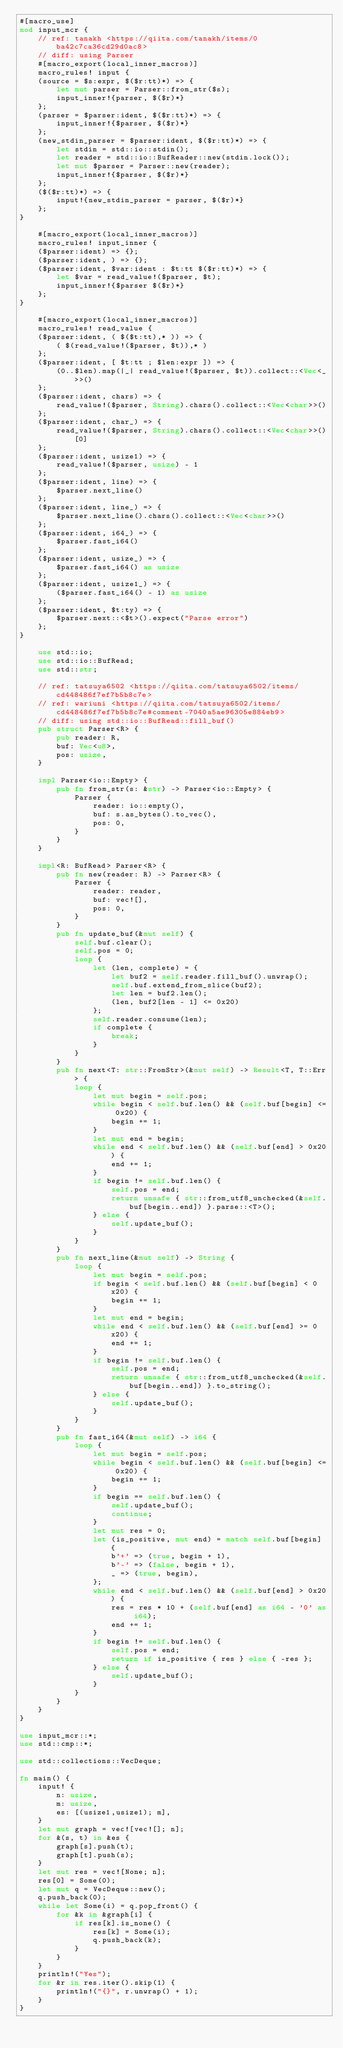Convert code to text. <code><loc_0><loc_0><loc_500><loc_500><_Rust_>#[macro_use]
mod input_mcr {
    // ref: tanakh <https://qiita.com/tanakh/items/0ba42c7ca36cd29d0ac8>
    // diff: using Parser
    #[macro_export(local_inner_macros)]
    macro_rules! input {
    (source = $s:expr, $($r:tt)*) => {
        let mut parser = Parser::from_str($s);
        input_inner!{parser, $($r)*}
    };
    (parser = $parser:ident, $($r:tt)*) => {
        input_inner!{$parser, $($r)*}
    };
    (new_stdin_parser = $parser:ident, $($r:tt)*) => {
        let stdin = std::io::stdin();
        let reader = std::io::BufReader::new(stdin.lock());
        let mut $parser = Parser::new(reader);
        input_inner!{$parser, $($r)*}
    };
    ($($r:tt)*) => {
        input!{new_stdin_parser = parser, $($r)*}
    };
}

    #[macro_export(local_inner_macros)]
    macro_rules! input_inner {
    ($parser:ident) => {};
    ($parser:ident, ) => {};
    ($parser:ident, $var:ident : $t:tt $($r:tt)*) => {
        let $var = read_value!($parser, $t);
        input_inner!{$parser $($r)*}
    };
}

    #[macro_export(local_inner_macros)]
    macro_rules! read_value {
    ($parser:ident, ( $($t:tt),* )) => {
        ( $(read_value!($parser, $t)),* )
    };
    ($parser:ident, [ $t:tt ; $len:expr ]) => {
        (0..$len).map(|_| read_value!($parser, $t)).collect::<Vec<_>>()
    };
    ($parser:ident, chars) => {
        read_value!($parser, String).chars().collect::<Vec<char>>()
    };
    ($parser:ident, char_) => {
        read_value!($parser, String).chars().collect::<Vec<char>>()[0]
    };
    ($parser:ident, usize1) => {
        read_value!($parser, usize) - 1
    };
    ($parser:ident, line) => {
        $parser.next_line()
    };
    ($parser:ident, line_) => {
        $parser.next_line().chars().collect::<Vec<char>>()
    };
    ($parser:ident, i64_) => {
        $parser.fast_i64()
    };
    ($parser:ident, usize_) => {
        $parser.fast_i64() as usize
    };
    ($parser:ident, usize1_) => {
        ($parser.fast_i64() - 1) as usize
    };
    ($parser:ident, $t:ty) => {
        $parser.next::<$t>().expect("Parse error")
    };
}

    use std::io;
    use std::io::BufRead;
    use std::str;

    // ref: tatsuya6502 <https://qiita.com/tatsuya6502/items/cd448486f7ef7b5b8c7e>
    // ref: wariuni <https://qiita.com/tatsuya6502/items/cd448486f7ef7b5b8c7e#comment-7040a5ae96305e884eb9>
    // diff: using std::io::BufRead::fill_buf()
    pub struct Parser<R> {
        pub reader: R,
        buf: Vec<u8>,
        pos: usize,
    }

    impl Parser<io::Empty> {
        pub fn from_str(s: &str) -> Parser<io::Empty> {
            Parser {
                reader: io::empty(),
                buf: s.as_bytes().to_vec(),
                pos: 0,
            }
        }
    }

    impl<R: BufRead> Parser<R> {
        pub fn new(reader: R) -> Parser<R> {
            Parser {
                reader: reader,
                buf: vec![],
                pos: 0,
            }
        }
        pub fn update_buf(&mut self) {
            self.buf.clear();
            self.pos = 0;
            loop {
                let (len, complete) = {
                    let buf2 = self.reader.fill_buf().unwrap();
                    self.buf.extend_from_slice(buf2);
                    let len = buf2.len();
                    (len, buf2[len - 1] <= 0x20)
                };
                self.reader.consume(len);
                if complete {
                    break;
                }
            }
        }
        pub fn next<T: str::FromStr>(&mut self) -> Result<T, T::Err> {
            loop {
                let mut begin = self.pos;
                while begin < self.buf.len() && (self.buf[begin] <= 0x20) {
                    begin += 1;
                }
                let mut end = begin;
                while end < self.buf.len() && (self.buf[end] > 0x20) {
                    end += 1;
                }
                if begin != self.buf.len() {
                    self.pos = end;
                    return unsafe { str::from_utf8_unchecked(&self.buf[begin..end]) }.parse::<T>();
                } else {
                    self.update_buf();
                }
            }
        }
        pub fn next_line(&mut self) -> String {
            loop {
                let mut begin = self.pos;
                if begin < self.buf.len() && (self.buf[begin] < 0x20) {
                    begin += 1;
                }
                let mut end = begin;
                while end < self.buf.len() && (self.buf[end] >= 0x20) {
                    end += 1;
                }
                if begin != self.buf.len() {
                    self.pos = end;
                    return unsafe { str::from_utf8_unchecked(&self.buf[begin..end]) }.to_string();
                } else {
                    self.update_buf();
                }
            }
        }
        pub fn fast_i64(&mut self) -> i64 {
            loop {
                let mut begin = self.pos;
                while begin < self.buf.len() && (self.buf[begin] <= 0x20) {
                    begin += 1;
                }
                if begin == self.buf.len() {
                    self.update_buf();
                    continue;
                }
                let mut res = 0;
                let (is_positive, mut end) = match self.buf[begin] {
                    b'+' => (true, begin + 1),
                    b'-' => (false, begin + 1),
                    _ => (true, begin),
                };
                while end < self.buf.len() && (self.buf[end] > 0x20) {
                    res = res * 10 + (self.buf[end] as i64 - '0' as i64);
                    end += 1;
                }
                if begin != self.buf.len() {
                    self.pos = end;
                    return if is_positive { res } else { -res };
                } else {
                    self.update_buf();
                }
            }
        }
    }
}

use input_mcr::*;
use std::cmp::*;

use std::collections::VecDeque;

fn main() {
    input! {
        n: usize,
        m: usize,
        es: [(usize1,usize1); m],
    }
    let mut graph = vec![vec![]; n];
    for &(s, t) in &es {
        graph[s].push(t);
        graph[t].push(s);
    }
    let mut res = vec![None; n];
    res[0] = Some(0);
    let mut q = VecDeque::new();
    q.push_back(0);
    while let Some(i) = q.pop_front() {
        for &k in &graph[i] {
            if res[k].is_none() {
                res[k] = Some(i);
                q.push_back(k);
            }
        }
    }
    println!("Yes");
    for &r in res.iter().skip(1) {
        println!("{}", r.unwrap() + 1);
    }
}

</code> 